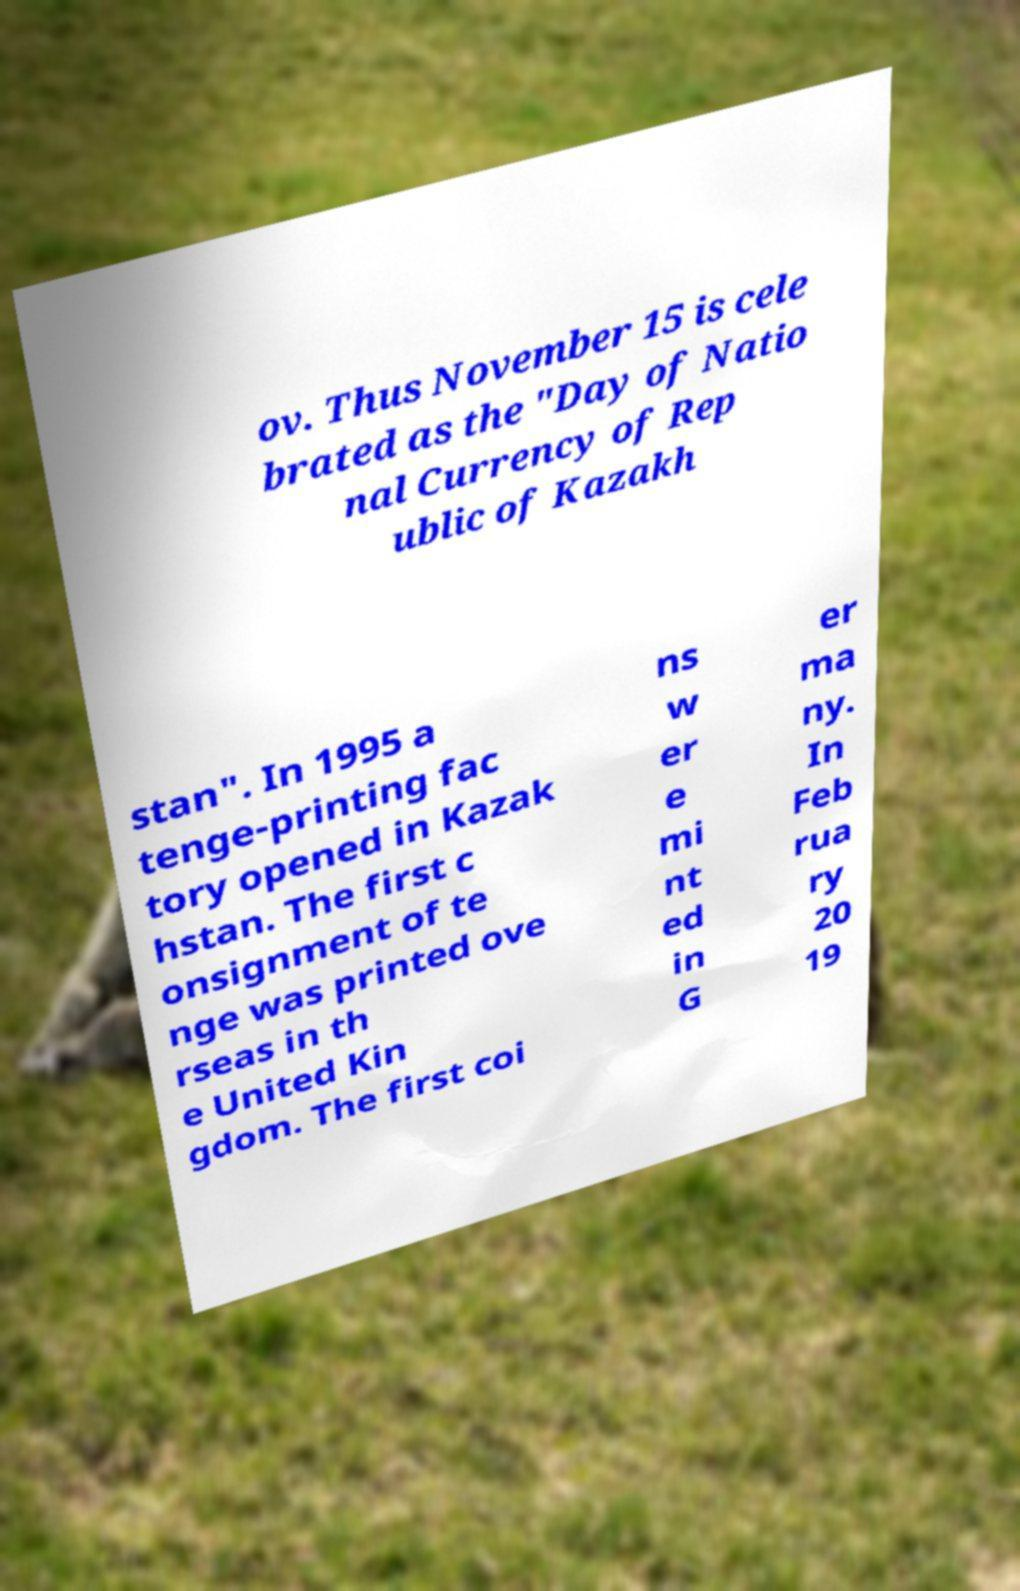For documentation purposes, I need the text within this image transcribed. Could you provide that? ov. Thus November 15 is cele brated as the "Day of Natio nal Currency of Rep ublic of Kazakh stan". In 1995 a tenge-printing fac tory opened in Kazak hstan. The first c onsignment of te nge was printed ove rseas in th e United Kin gdom. The first coi ns w er e mi nt ed in G er ma ny. In Feb rua ry 20 19 